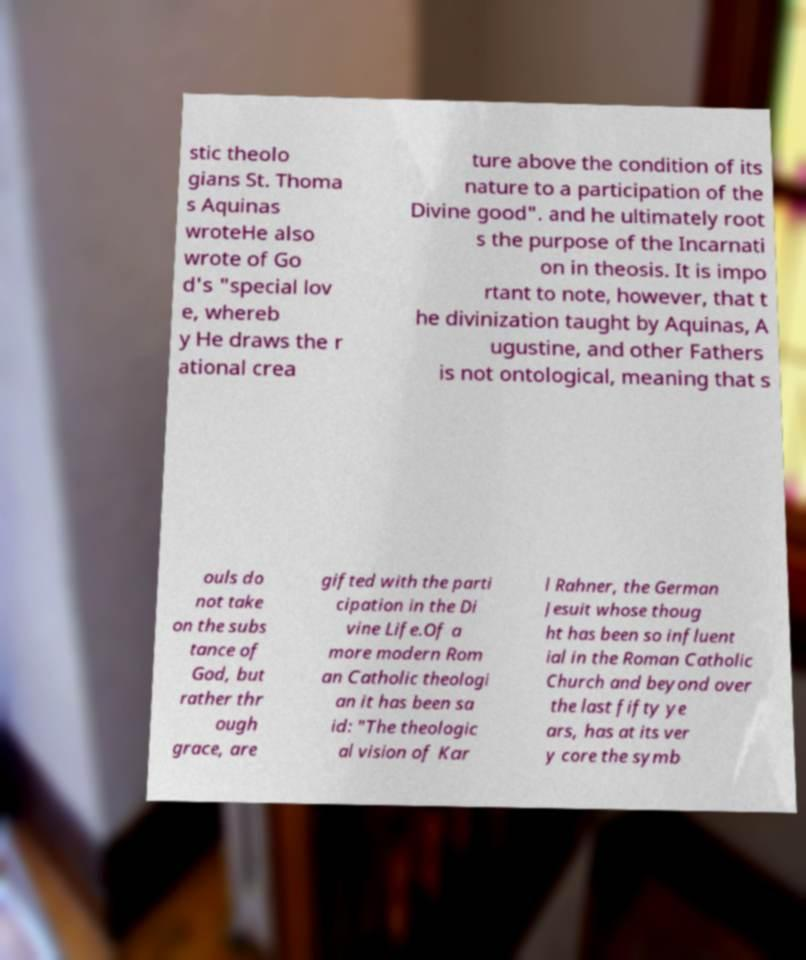Can you accurately transcribe the text from the provided image for me? stic theolo gians St. Thoma s Aquinas wroteHe also wrote of Go d's "special lov e, whereb y He draws the r ational crea ture above the condition of its nature to a participation of the Divine good". and he ultimately root s the purpose of the Incarnati on in theosis. It is impo rtant to note, however, that t he divinization taught by Aquinas, A ugustine, and other Fathers is not ontological, meaning that s ouls do not take on the subs tance of God, but rather thr ough grace, are gifted with the parti cipation in the Di vine Life.Of a more modern Rom an Catholic theologi an it has been sa id: "The theologic al vision of Kar l Rahner, the German Jesuit whose thoug ht has been so influent ial in the Roman Catholic Church and beyond over the last fifty ye ars, has at its ver y core the symb 